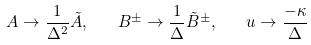Convert formula to latex. <formula><loc_0><loc_0><loc_500><loc_500>A \to \frac { 1 } { \Delta ^ { 2 } } \tilde { A } , \quad B ^ { \pm } \to \frac { 1 } { \Delta } \tilde { B } ^ { \pm } , \quad u \to \frac { - \kappa } { \Delta }</formula> 